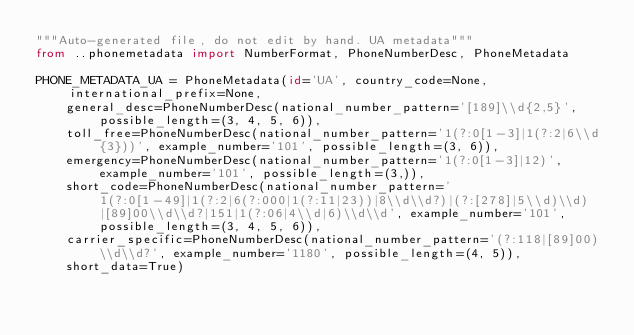Convert code to text. <code><loc_0><loc_0><loc_500><loc_500><_Python_>"""Auto-generated file, do not edit by hand. UA metadata"""
from ..phonemetadata import NumberFormat, PhoneNumberDesc, PhoneMetadata

PHONE_METADATA_UA = PhoneMetadata(id='UA', country_code=None, international_prefix=None,
    general_desc=PhoneNumberDesc(national_number_pattern='[189]\\d{2,5}', possible_length=(3, 4, 5, 6)),
    toll_free=PhoneNumberDesc(national_number_pattern='1(?:0[1-3]|1(?:2|6\\d{3}))', example_number='101', possible_length=(3, 6)),
    emergency=PhoneNumberDesc(national_number_pattern='1(?:0[1-3]|12)', example_number='101', possible_length=(3,)),
    short_code=PhoneNumberDesc(national_number_pattern='1(?:0[1-49]|1(?:2|6(?:000|1(?:11|23))|8\\d\\d?)|(?:[278]|5\\d)\\d)|[89]00\\d\\d?|151|1(?:06|4\\d|6)\\d\\d', example_number='101', possible_length=(3, 4, 5, 6)),
    carrier_specific=PhoneNumberDesc(national_number_pattern='(?:118|[89]00)\\d\\d?', example_number='1180', possible_length=(4, 5)),
    short_data=True)
</code> 